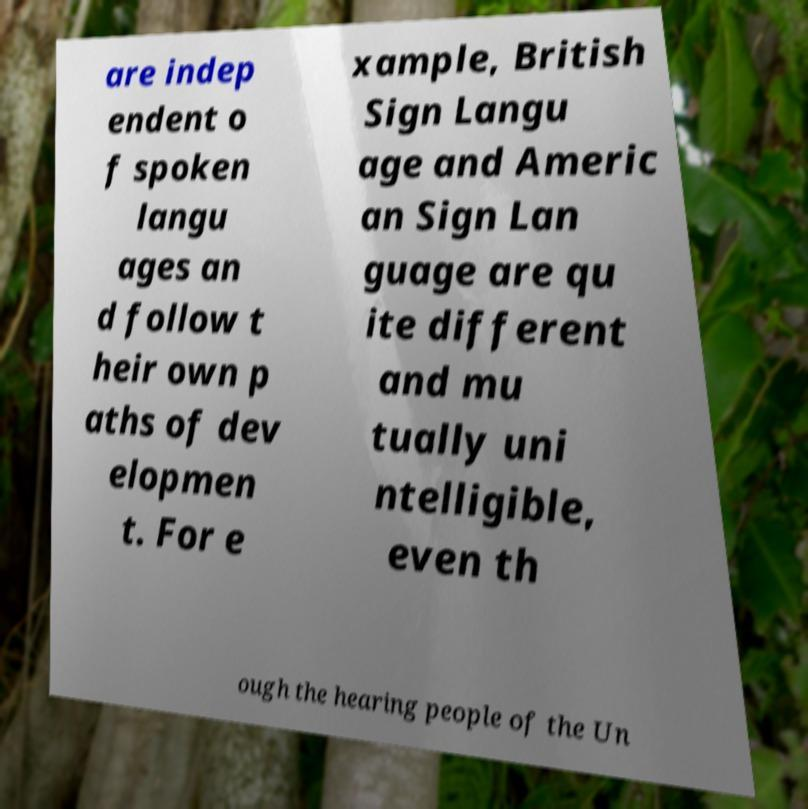Could you extract and type out the text from this image? are indep endent o f spoken langu ages an d follow t heir own p aths of dev elopmen t. For e xample, British Sign Langu age and Americ an Sign Lan guage are qu ite different and mu tually uni ntelligible, even th ough the hearing people of the Un 